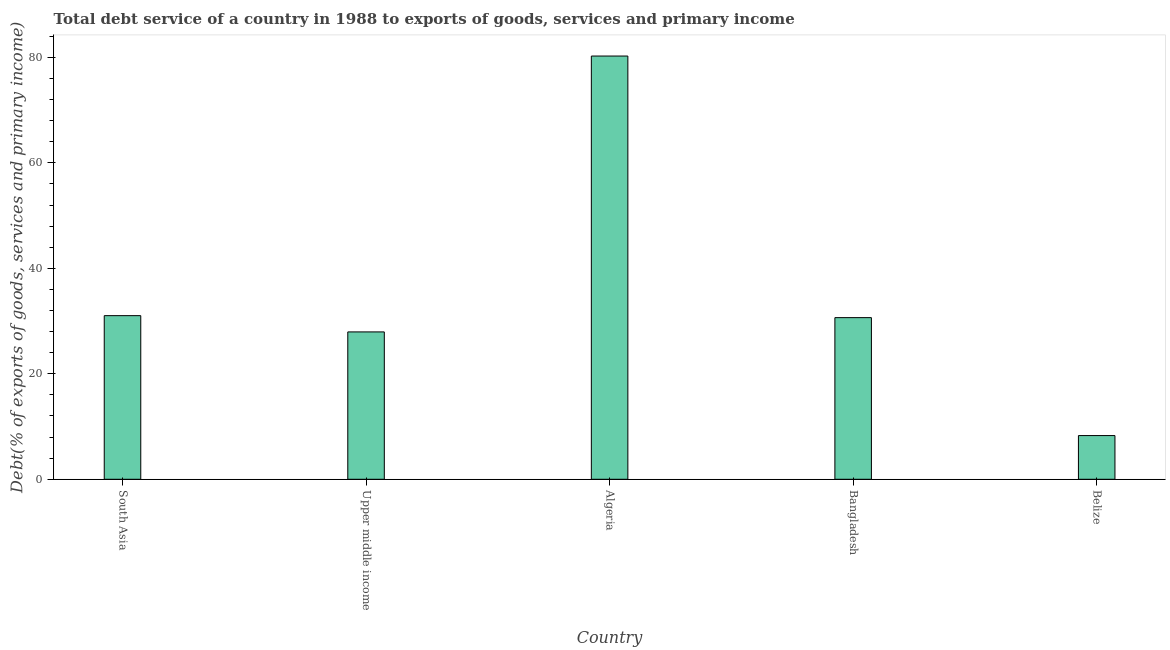Does the graph contain any zero values?
Provide a short and direct response. No. Does the graph contain grids?
Offer a terse response. No. What is the title of the graph?
Your response must be concise. Total debt service of a country in 1988 to exports of goods, services and primary income. What is the label or title of the Y-axis?
Your response must be concise. Debt(% of exports of goods, services and primary income). What is the total debt service in Belize?
Your response must be concise. 8.29. Across all countries, what is the maximum total debt service?
Provide a succinct answer. 80.26. Across all countries, what is the minimum total debt service?
Ensure brevity in your answer.  8.29. In which country was the total debt service maximum?
Give a very brief answer. Algeria. In which country was the total debt service minimum?
Your answer should be compact. Belize. What is the sum of the total debt service?
Give a very brief answer. 178.17. What is the difference between the total debt service in Algeria and Upper middle income?
Make the answer very short. 52.31. What is the average total debt service per country?
Provide a succinct answer. 35.63. What is the median total debt service?
Provide a short and direct response. 30.65. In how many countries, is the total debt service greater than 20 %?
Keep it short and to the point. 4. What is the ratio of the total debt service in South Asia to that in Upper middle income?
Ensure brevity in your answer.  1.11. Is the total debt service in Bangladesh less than that in South Asia?
Offer a terse response. Yes. Is the difference between the total debt service in Algeria and Belize greater than the difference between any two countries?
Your response must be concise. Yes. What is the difference between the highest and the second highest total debt service?
Ensure brevity in your answer.  49.23. Is the sum of the total debt service in Bangladesh and Belize greater than the maximum total debt service across all countries?
Your response must be concise. No. What is the difference between the highest and the lowest total debt service?
Provide a short and direct response. 71.97. In how many countries, is the total debt service greater than the average total debt service taken over all countries?
Offer a very short reply. 1. Are all the bars in the graph horizontal?
Provide a succinct answer. No. What is the difference between two consecutive major ticks on the Y-axis?
Your response must be concise. 20. What is the Debt(% of exports of goods, services and primary income) in South Asia?
Make the answer very short. 31.03. What is the Debt(% of exports of goods, services and primary income) in Upper middle income?
Provide a short and direct response. 27.94. What is the Debt(% of exports of goods, services and primary income) of Algeria?
Offer a terse response. 80.26. What is the Debt(% of exports of goods, services and primary income) of Bangladesh?
Provide a succinct answer. 30.65. What is the Debt(% of exports of goods, services and primary income) in Belize?
Your response must be concise. 8.29. What is the difference between the Debt(% of exports of goods, services and primary income) in South Asia and Upper middle income?
Provide a succinct answer. 3.08. What is the difference between the Debt(% of exports of goods, services and primary income) in South Asia and Algeria?
Offer a terse response. -49.23. What is the difference between the Debt(% of exports of goods, services and primary income) in South Asia and Bangladesh?
Make the answer very short. 0.38. What is the difference between the Debt(% of exports of goods, services and primary income) in South Asia and Belize?
Your answer should be very brief. 22.74. What is the difference between the Debt(% of exports of goods, services and primary income) in Upper middle income and Algeria?
Give a very brief answer. -52.32. What is the difference between the Debt(% of exports of goods, services and primary income) in Upper middle income and Bangladesh?
Keep it short and to the point. -2.71. What is the difference between the Debt(% of exports of goods, services and primary income) in Upper middle income and Belize?
Keep it short and to the point. 19.66. What is the difference between the Debt(% of exports of goods, services and primary income) in Algeria and Bangladesh?
Your response must be concise. 49.61. What is the difference between the Debt(% of exports of goods, services and primary income) in Algeria and Belize?
Keep it short and to the point. 71.97. What is the difference between the Debt(% of exports of goods, services and primary income) in Bangladesh and Belize?
Your answer should be very brief. 22.36. What is the ratio of the Debt(% of exports of goods, services and primary income) in South Asia to that in Upper middle income?
Give a very brief answer. 1.11. What is the ratio of the Debt(% of exports of goods, services and primary income) in South Asia to that in Algeria?
Provide a short and direct response. 0.39. What is the ratio of the Debt(% of exports of goods, services and primary income) in South Asia to that in Belize?
Offer a very short reply. 3.74. What is the ratio of the Debt(% of exports of goods, services and primary income) in Upper middle income to that in Algeria?
Provide a succinct answer. 0.35. What is the ratio of the Debt(% of exports of goods, services and primary income) in Upper middle income to that in Bangladesh?
Your answer should be very brief. 0.91. What is the ratio of the Debt(% of exports of goods, services and primary income) in Upper middle income to that in Belize?
Your answer should be compact. 3.37. What is the ratio of the Debt(% of exports of goods, services and primary income) in Algeria to that in Bangladesh?
Offer a terse response. 2.62. What is the ratio of the Debt(% of exports of goods, services and primary income) in Algeria to that in Belize?
Provide a succinct answer. 9.68. What is the ratio of the Debt(% of exports of goods, services and primary income) in Bangladesh to that in Belize?
Your response must be concise. 3.7. 